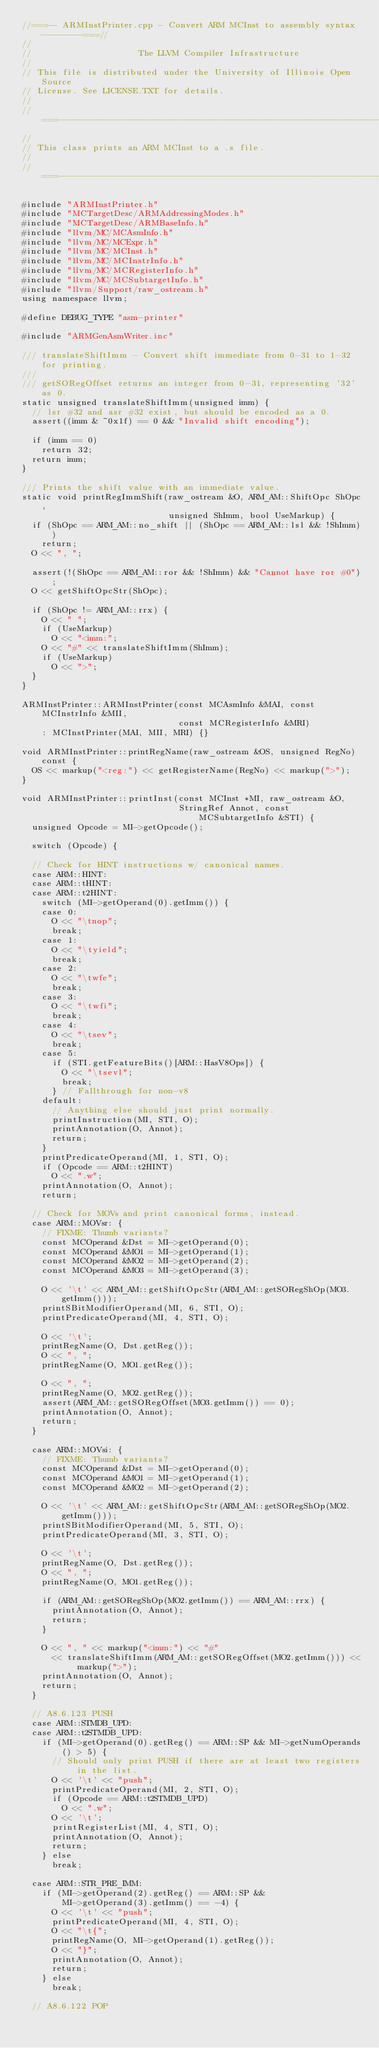Convert code to text. <code><loc_0><loc_0><loc_500><loc_500><_C++_>//===-- ARMInstPrinter.cpp - Convert ARM MCInst to assembly syntax --------===//
//
//                     The LLVM Compiler Infrastructure
//
// This file is distributed under the University of Illinois Open Source
// License. See LICENSE.TXT for details.
//
//===----------------------------------------------------------------------===//
//
// This class prints an ARM MCInst to a .s file.
//
//===----------------------------------------------------------------------===//

#include "ARMInstPrinter.h"
#include "MCTargetDesc/ARMAddressingModes.h"
#include "MCTargetDesc/ARMBaseInfo.h"
#include "llvm/MC/MCAsmInfo.h"
#include "llvm/MC/MCExpr.h"
#include "llvm/MC/MCInst.h"
#include "llvm/MC/MCInstrInfo.h"
#include "llvm/MC/MCRegisterInfo.h"
#include "llvm/MC/MCSubtargetInfo.h"
#include "llvm/Support/raw_ostream.h"
using namespace llvm;

#define DEBUG_TYPE "asm-printer"

#include "ARMGenAsmWriter.inc"

/// translateShiftImm - Convert shift immediate from 0-31 to 1-32 for printing.
///
/// getSORegOffset returns an integer from 0-31, representing '32' as 0.
static unsigned translateShiftImm(unsigned imm) {
  // lsr #32 and asr #32 exist, but should be encoded as a 0.
  assert((imm & ~0x1f) == 0 && "Invalid shift encoding");

  if (imm == 0)
    return 32;
  return imm;
}

/// Prints the shift value with an immediate value.
static void printRegImmShift(raw_ostream &O, ARM_AM::ShiftOpc ShOpc,
                             unsigned ShImm, bool UseMarkup) {
  if (ShOpc == ARM_AM::no_shift || (ShOpc == ARM_AM::lsl && !ShImm))
    return;
  O << ", ";

  assert(!(ShOpc == ARM_AM::ror && !ShImm) && "Cannot have ror #0");
  O << getShiftOpcStr(ShOpc);

  if (ShOpc != ARM_AM::rrx) {
    O << " ";
    if (UseMarkup)
      O << "<imm:";
    O << "#" << translateShiftImm(ShImm);
    if (UseMarkup)
      O << ">";
  }
}

ARMInstPrinter::ARMInstPrinter(const MCAsmInfo &MAI, const MCInstrInfo &MII,
                               const MCRegisterInfo &MRI)
    : MCInstPrinter(MAI, MII, MRI) {}

void ARMInstPrinter::printRegName(raw_ostream &OS, unsigned RegNo) const {
  OS << markup("<reg:") << getRegisterName(RegNo) << markup(">");
}

void ARMInstPrinter::printInst(const MCInst *MI, raw_ostream &O,
                               StringRef Annot, const MCSubtargetInfo &STI) {
  unsigned Opcode = MI->getOpcode();

  switch (Opcode) {

  // Check for HINT instructions w/ canonical names.
  case ARM::HINT:
  case ARM::tHINT:
  case ARM::t2HINT:
    switch (MI->getOperand(0).getImm()) {
    case 0:
      O << "\tnop";
      break;
    case 1:
      O << "\tyield";
      break;
    case 2:
      O << "\twfe";
      break;
    case 3:
      O << "\twfi";
      break;
    case 4:
      O << "\tsev";
      break;
    case 5:
      if (STI.getFeatureBits()[ARM::HasV8Ops]) {
        O << "\tsevl";
        break;
      } // Fallthrough for non-v8
    default:
      // Anything else should just print normally.
      printInstruction(MI, STI, O);
      printAnnotation(O, Annot);
      return;
    }
    printPredicateOperand(MI, 1, STI, O);
    if (Opcode == ARM::t2HINT)
      O << ".w";
    printAnnotation(O, Annot);
    return;

  // Check for MOVs and print canonical forms, instead.
  case ARM::MOVsr: {
    // FIXME: Thumb variants?
    const MCOperand &Dst = MI->getOperand(0);
    const MCOperand &MO1 = MI->getOperand(1);
    const MCOperand &MO2 = MI->getOperand(2);
    const MCOperand &MO3 = MI->getOperand(3);

    O << '\t' << ARM_AM::getShiftOpcStr(ARM_AM::getSORegShOp(MO3.getImm()));
    printSBitModifierOperand(MI, 6, STI, O);
    printPredicateOperand(MI, 4, STI, O);

    O << '\t';
    printRegName(O, Dst.getReg());
    O << ", ";
    printRegName(O, MO1.getReg());

    O << ", ";
    printRegName(O, MO2.getReg());
    assert(ARM_AM::getSORegOffset(MO3.getImm()) == 0);
    printAnnotation(O, Annot);
    return;
  }

  case ARM::MOVsi: {
    // FIXME: Thumb variants?
    const MCOperand &Dst = MI->getOperand(0);
    const MCOperand &MO1 = MI->getOperand(1);
    const MCOperand &MO2 = MI->getOperand(2);

    O << '\t' << ARM_AM::getShiftOpcStr(ARM_AM::getSORegShOp(MO2.getImm()));
    printSBitModifierOperand(MI, 5, STI, O);
    printPredicateOperand(MI, 3, STI, O);

    O << '\t';
    printRegName(O, Dst.getReg());
    O << ", ";
    printRegName(O, MO1.getReg());

    if (ARM_AM::getSORegShOp(MO2.getImm()) == ARM_AM::rrx) {
      printAnnotation(O, Annot);
      return;
    }

    O << ", " << markup("<imm:") << "#"
      << translateShiftImm(ARM_AM::getSORegOffset(MO2.getImm())) << markup(">");
    printAnnotation(O, Annot);
    return;
  }

  // A8.6.123 PUSH
  case ARM::STMDB_UPD:
  case ARM::t2STMDB_UPD:
    if (MI->getOperand(0).getReg() == ARM::SP && MI->getNumOperands() > 5) {
      // Should only print PUSH if there are at least two registers in the list.
      O << '\t' << "push";
      printPredicateOperand(MI, 2, STI, O);
      if (Opcode == ARM::t2STMDB_UPD)
        O << ".w";
      O << '\t';
      printRegisterList(MI, 4, STI, O);
      printAnnotation(O, Annot);
      return;
    } else
      break;

  case ARM::STR_PRE_IMM:
    if (MI->getOperand(2).getReg() == ARM::SP &&
        MI->getOperand(3).getImm() == -4) {
      O << '\t' << "push";
      printPredicateOperand(MI, 4, STI, O);
      O << "\t{";
      printRegName(O, MI->getOperand(1).getReg());
      O << "}";
      printAnnotation(O, Annot);
      return;
    } else
      break;

  // A8.6.122 POP</code> 